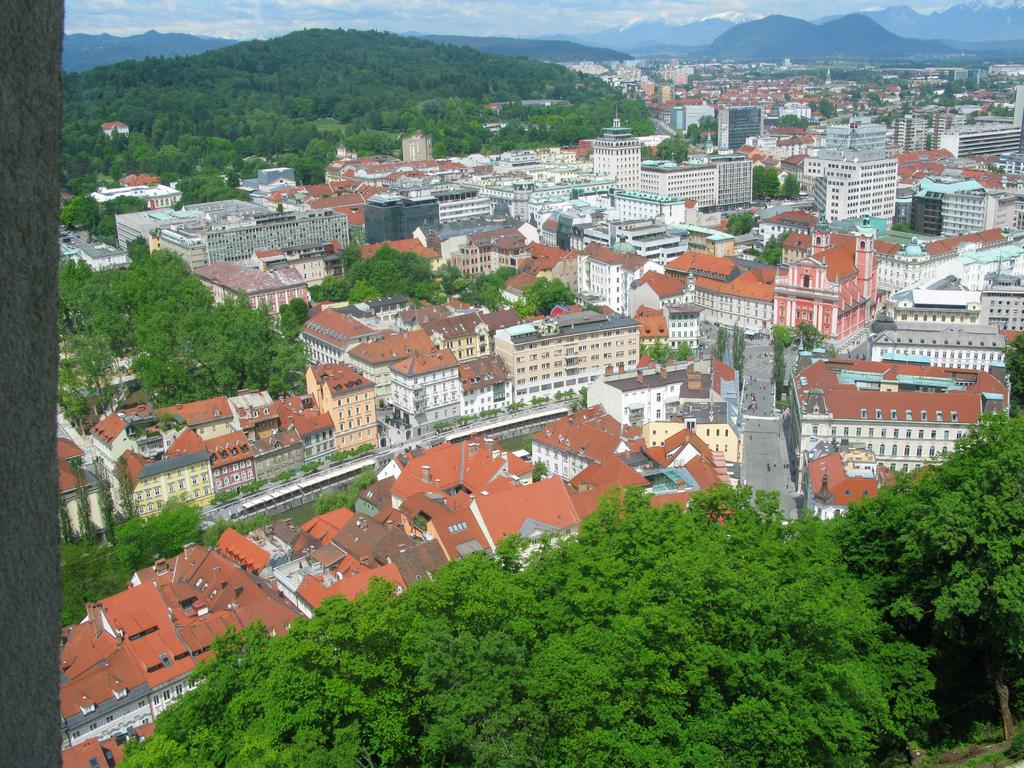What type of natural elements can be seen in the image? There are trees in the image. What type of man-made structures are present in the image? There are buildings in the image. What can be seen in the distance in the image? There are mountains visible in the background of the image. What type of mark can be seen on the pot in the image? There is no pot present in the image, so there is no mark to be seen. 